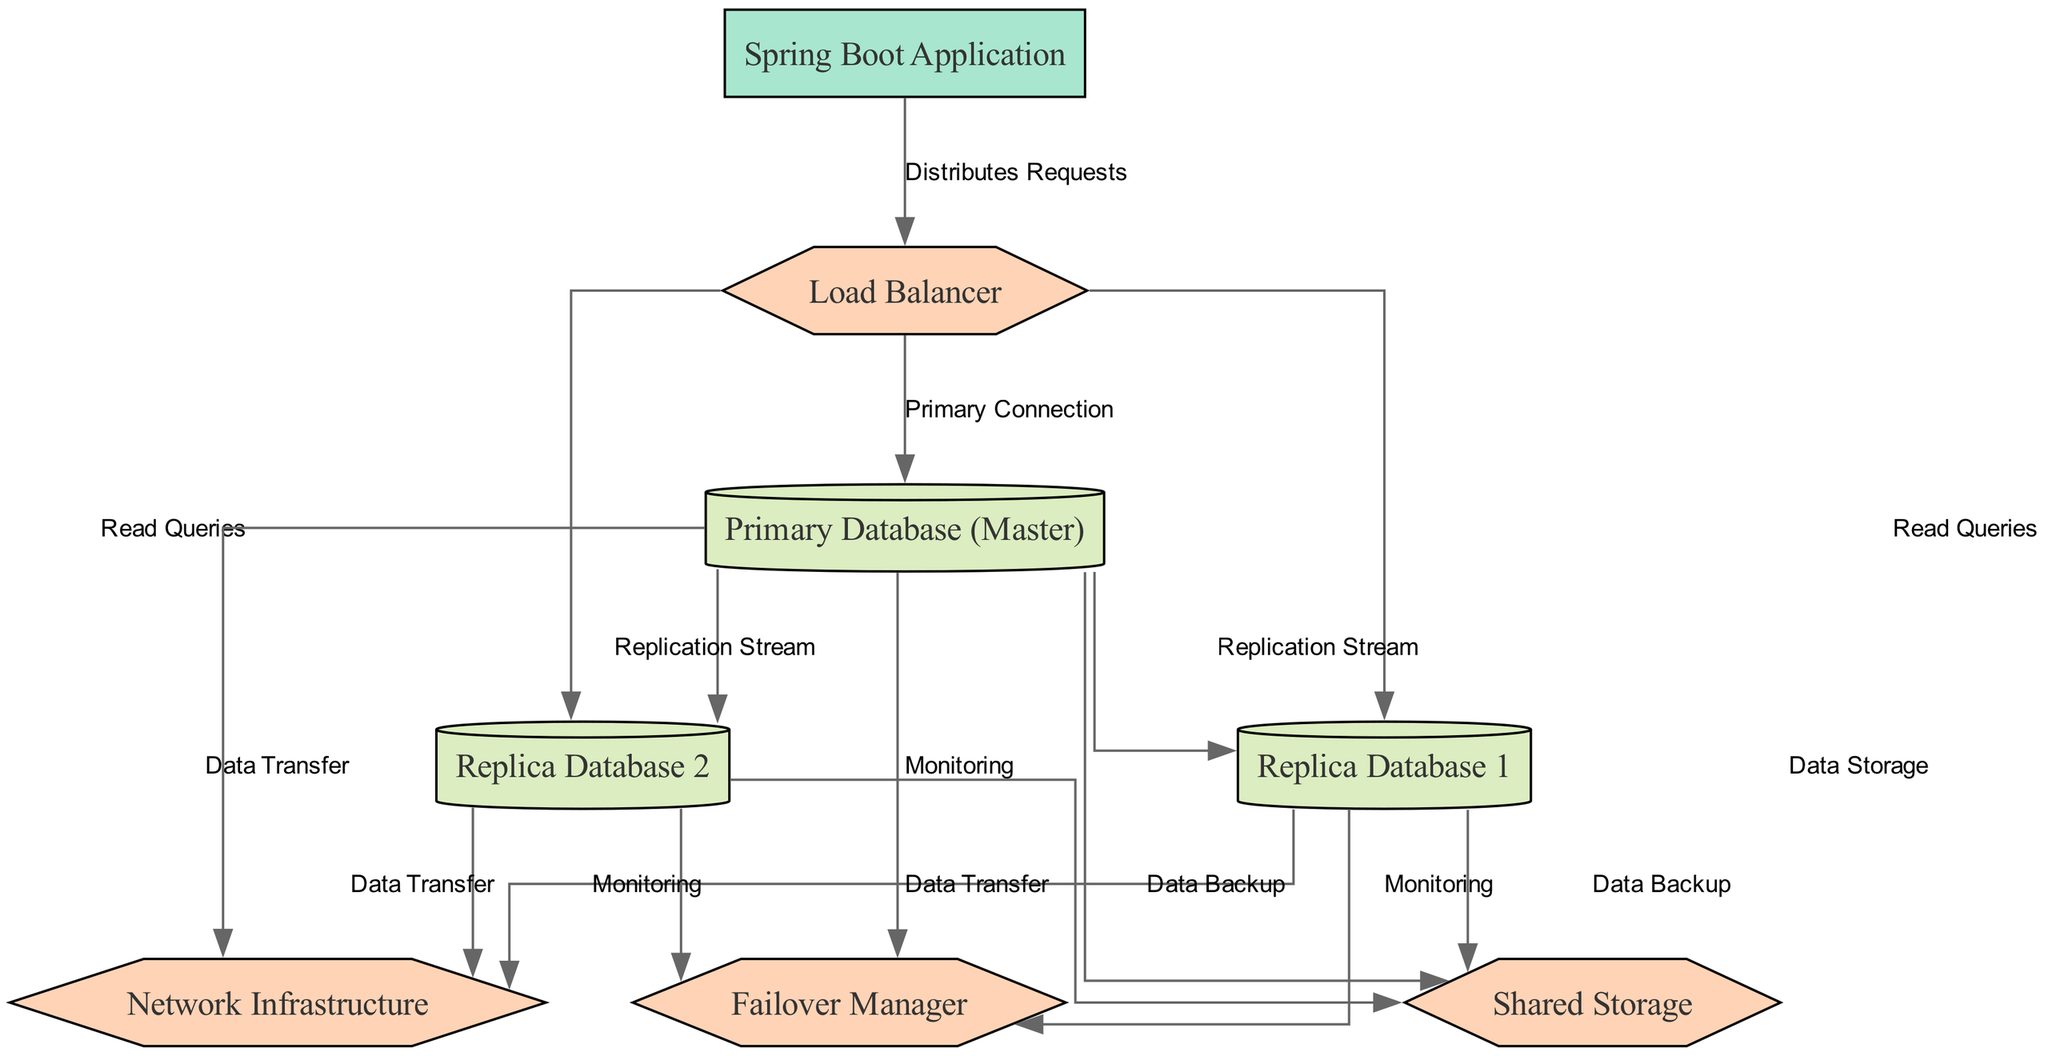What is the label of the node representing the main application? The main application in the diagram is represented by the node labeled "Spring Boot Application." This label is clearly displayed as part of the nodes showcased in the diagram's structure.
Answer: Spring Boot Application How many replica databases are shown in the diagram? The diagram presents two replica databases specifically labeled as "Replica Database 1" and "Replica Database 2." By counting these distinctive nodes, we can ascertain the total number.
Answer: 2 What role does the Load Balancer play in relation to the databases? The Load Balancer's role in the diagram is to handle requests by directing them to the primary database for primary connections and distributing read queries to both replica databases. This relationship is established through the edges connecting the Load Balancer to these databases.
Answer: Distributes Requests Which entity is responsible for monitoring the databases? The Failover Manager is depicted in the diagram as the entity tasked with monitoring all databases, including the primary and the replicas. This can be confirmed by the connections leading from each database to the Failover Manager for monitoring purposes.
Answer: Failover Manager What is the function of the Replication Stream in the diagram? The Replication Stream in the diagram signifies the process through which updates from the Primary Database are propagated to both replica databases. This is indicated by the edges extending from the Primary Database to each of the replicas labeled accordingly.
Answer: Updates to replicas What kind of infrastructure is shared among the databases? The infrastructure labeled "Shared Storage" serves as a common data storage solution for the databases. Each database (both primary and replicas) has a connection to this shared storage for data-related tasks, which is evident from the connecting edges in the diagram.
Answer: Shared Storage How does the primary database connect with the network? The primary database connects to the network through a labeled edge indicating "Data Transfer." This connection allows data interaction and communication with other components in the system, reflecting the essential flow illustrated in the diagram.
Answer: Data Transfer What type of storage is utilized by the replica databases for data backup? The replica databases utilize the "Shared Storage" indicated in the diagram for data backup purposes. Each replica database has an established connection leading to this shared storage component, highlighting its function in data retention and recovery.
Answer: Data Backup What does the network infrastructure connect to? The network infrastructure connects to the primary database and both replica databases, as depicted by the edges labeled "Data Transfer." This connection is crucial for ensuring that all databases can communicate effectively with one another and the overall system.
Answer: Primary and Replica Databases 